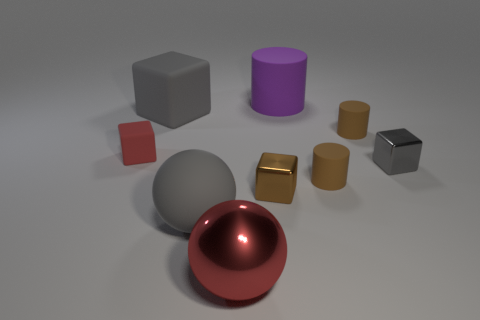Subtract all tiny brown cylinders. How many cylinders are left? 1 Subtract all red cubes. How many cubes are left? 3 Add 1 large objects. How many objects exist? 10 Subtract 1 balls. How many balls are left? 1 Subtract all cylinders. How many objects are left? 6 Add 5 cyan rubber blocks. How many cyan rubber blocks exist? 5 Subtract 0 red cylinders. How many objects are left? 9 Subtract all green cylinders. Subtract all blue balls. How many cylinders are left? 3 Subtract all gray cylinders. How many cyan cubes are left? 0 Subtract all big purple matte cylinders. Subtract all tiny cylinders. How many objects are left? 6 